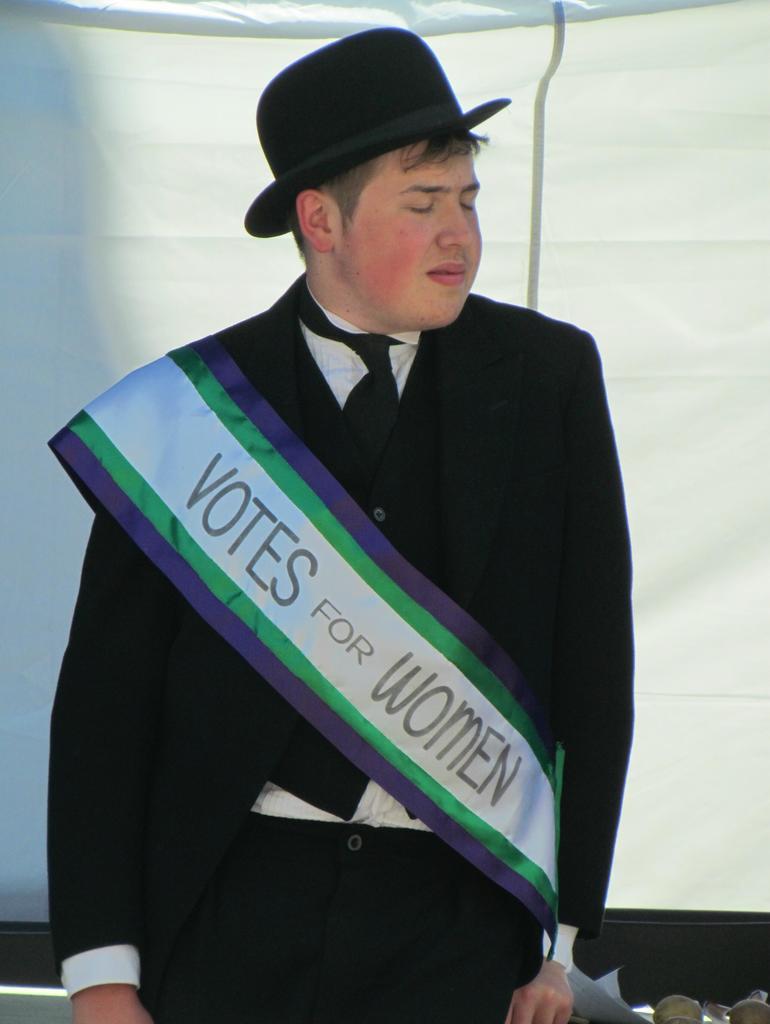Please provide a concise description of this image. In the image we can see there is a man standing, he is wearing formal suit and hat. There is a pageant ribbon on which it's written ¨Votes for Women¨. Behind there is a white curtain. 